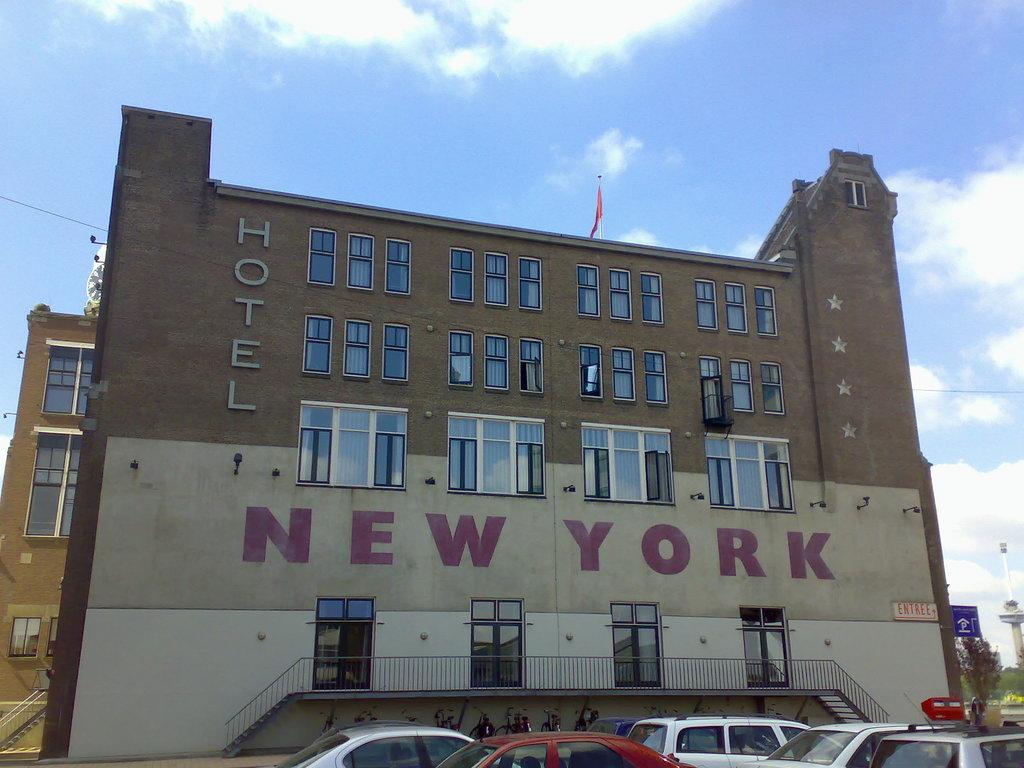Could you give a brief overview of what you see in this image? In this picture we can see vehicles, name boards, fence, buildings with windows and some objects and in the background we can see trees and the sky with clouds. 